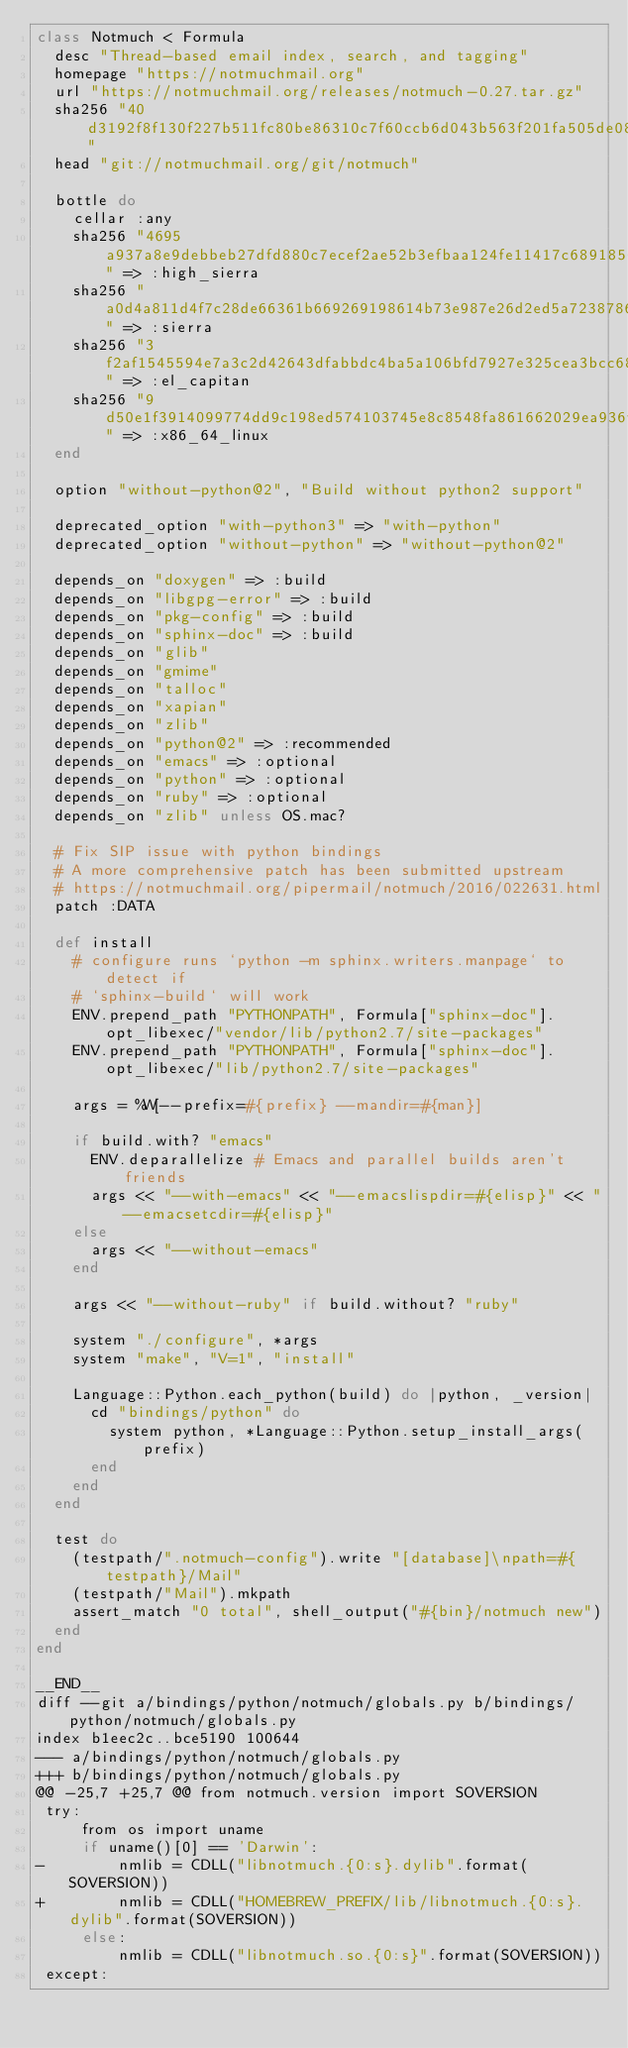Convert code to text. <code><loc_0><loc_0><loc_500><loc_500><_Ruby_>class Notmuch < Formula
  desc "Thread-based email index, search, and tagging"
  homepage "https://notmuchmail.org"
  url "https://notmuchmail.org/releases/notmuch-0.27.tar.gz"
  sha256 "40d3192f8f130f227b511fc80be86310c7f60ccb6d043b563f201fa505de0876"
  head "git://notmuchmail.org/git/notmuch"

  bottle do
    cellar :any
    sha256 "4695a937a8e9debbeb27dfd880c7ecef2ae52b3efbaa124fe11417c6891856f1" => :high_sierra
    sha256 "a0d4a811d4f7c28de66361b669269198614b73e987e26d2ed5a7238786167766" => :sierra
    sha256 "3f2af1545594e7a3c2d42643dfabbdc4ba5a106bfd7927e325cea3bcc68e979c" => :el_capitan
    sha256 "9d50e1f3914099774dd9c198ed574103745e8c8548fa861662029ea936fb4458" => :x86_64_linux
  end

  option "without-python@2", "Build without python2 support"

  deprecated_option "with-python3" => "with-python"
  deprecated_option "without-python" => "without-python@2"

  depends_on "doxygen" => :build
  depends_on "libgpg-error" => :build
  depends_on "pkg-config" => :build
  depends_on "sphinx-doc" => :build
  depends_on "glib"
  depends_on "gmime"
  depends_on "talloc"
  depends_on "xapian"
  depends_on "zlib"
  depends_on "python@2" => :recommended
  depends_on "emacs" => :optional
  depends_on "python" => :optional
  depends_on "ruby" => :optional
  depends_on "zlib" unless OS.mac?

  # Fix SIP issue with python bindings
  # A more comprehensive patch has been submitted upstream
  # https://notmuchmail.org/pipermail/notmuch/2016/022631.html
  patch :DATA

  def install
    # configure runs `python -m sphinx.writers.manpage` to detect if
    # `sphinx-build` will work
    ENV.prepend_path "PYTHONPATH", Formula["sphinx-doc"].opt_libexec/"vendor/lib/python2.7/site-packages"
    ENV.prepend_path "PYTHONPATH", Formula["sphinx-doc"].opt_libexec/"lib/python2.7/site-packages"

    args = %W[--prefix=#{prefix} --mandir=#{man}]

    if build.with? "emacs"
      ENV.deparallelize # Emacs and parallel builds aren't friends
      args << "--with-emacs" << "--emacslispdir=#{elisp}" << "--emacsetcdir=#{elisp}"
    else
      args << "--without-emacs"
    end

    args << "--without-ruby" if build.without? "ruby"

    system "./configure", *args
    system "make", "V=1", "install"

    Language::Python.each_python(build) do |python, _version|
      cd "bindings/python" do
        system python, *Language::Python.setup_install_args(prefix)
      end
    end
  end

  test do
    (testpath/".notmuch-config").write "[database]\npath=#{testpath}/Mail"
    (testpath/"Mail").mkpath
    assert_match "0 total", shell_output("#{bin}/notmuch new")
  end
end

__END__
diff --git a/bindings/python/notmuch/globals.py b/bindings/python/notmuch/globals.py
index b1eec2c..bce5190 100644
--- a/bindings/python/notmuch/globals.py
+++ b/bindings/python/notmuch/globals.py
@@ -25,7 +25,7 @@ from notmuch.version import SOVERSION
 try:
     from os import uname
     if uname()[0] == 'Darwin':
-        nmlib = CDLL("libnotmuch.{0:s}.dylib".format(SOVERSION))
+        nmlib = CDLL("HOMEBREW_PREFIX/lib/libnotmuch.{0:s}.dylib".format(SOVERSION))
     else:
         nmlib = CDLL("libnotmuch.so.{0:s}".format(SOVERSION))
 except:
</code> 